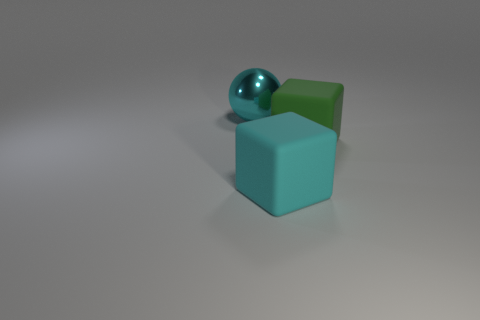Are there an equal number of green blocks that are behind the shiny sphere and metallic blocks?
Give a very brief answer. Yes. There is a cyan metallic ball; does it have the same size as the block behind the cyan matte object?
Make the answer very short. Yes. There is a large cyan object that is right of the big ball; what shape is it?
Your answer should be compact. Cube. Are there any other things that have the same shape as the green rubber thing?
Offer a very short reply. Yes. Is there a large cyan matte thing?
Give a very brief answer. Yes. There is a cyan thing that is right of the cyan metal object; is its size the same as the cyan thing that is behind the large green rubber thing?
Ensure brevity in your answer.  Yes. What is the big thing that is on the left side of the large green thing and behind the cyan matte cube made of?
Your answer should be compact. Metal. There is a cyan ball; how many green cubes are on the right side of it?
Make the answer very short. 1. Are there any other things that are the same size as the cyan cube?
Provide a short and direct response. Yes. What is the color of the object that is the same material as the cyan block?
Give a very brief answer. Green. 